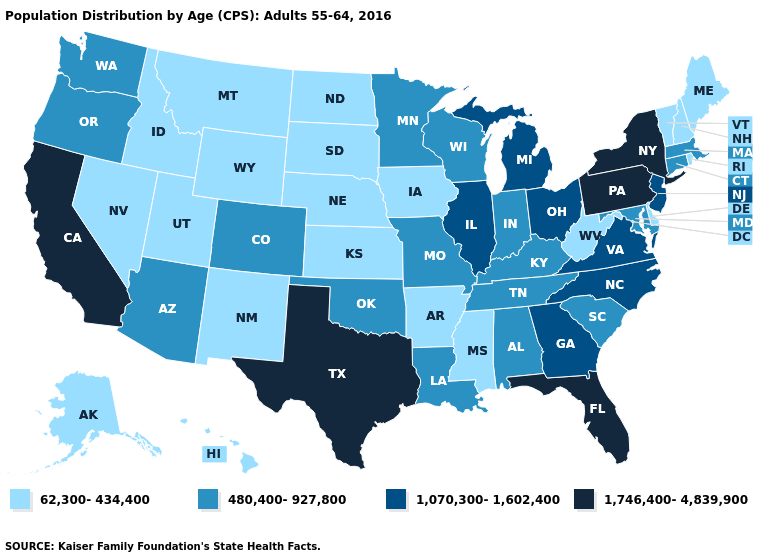Name the states that have a value in the range 480,400-927,800?
Quick response, please. Alabama, Arizona, Colorado, Connecticut, Indiana, Kentucky, Louisiana, Maryland, Massachusetts, Minnesota, Missouri, Oklahoma, Oregon, South Carolina, Tennessee, Washington, Wisconsin. Among the states that border Michigan , which have the highest value?
Quick response, please. Ohio. Name the states that have a value in the range 62,300-434,400?
Quick response, please. Alaska, Arkansas, Delaware, Hawaii, Idaho, Iowa, Kansas, Maine, Mississippi, Montana, Nebraska, Nevada, New Hampshire, New Mexico, North Dakota, Rhode Island, South Dakota, Utah, Vermont, West Virginia, Wyoming. Which states have the lowest value in the USA?
Answer briefly. Alaska, Arkansas, Delaware, Hawaii, Idaho, Iowa, Kansas, Maine, Mississippi, Montana, Nebraska, Nevada, New Hampshire, New Mexico, North Dakota, Rhode Island, South Dakota, Utah, Vermont, West Virginia, Wyoming. What is the lowest value in the USA?
Write a very short answer. 62,300-434,400. Name the states that have a value in the range 1,746,400-4,839,900?
Keep it brief. California, Florida, New York, Pennsylvania, Texas. What is the highest value in the West ?
Answer briefly. 1,746,400-4,839,900. Name the states that have a value in the range 1,070,300-1,602,400?
Write a very short answer. Georgia, Illinois, Michigan, New Jersey, North Carolina, Ohio, Virginia. What is the lowest value in the West?
Quick response, please. 62,300-434,400. Name the states that have a value in the range 62,300-434,400?
Short answer required. Alaska, Arkansas, Delaware, Hawaii, Idaho, Iowa, Kansas, Maine, Mississippi, Montana, Nebraska, Nevada, New Hampshire, New Mexico, North Dakota, Rhode Island, South Dakota, Utah, Vermont, West Virginia, Wyoming. Does Indiana have a higher value than Maine?
Quick response, please. Yes. What is the lowest value in states that border Massachusetts?
Answer briefly. 62,300-434,400. Does South Carolina have the lowest value in the USA?
Short answer required. No. What is the value of Ohio?
Write a very short answer. 1,070,300-1,602,400. Does California have a higher value than Michigan?
Write a very short answer. Yes. 